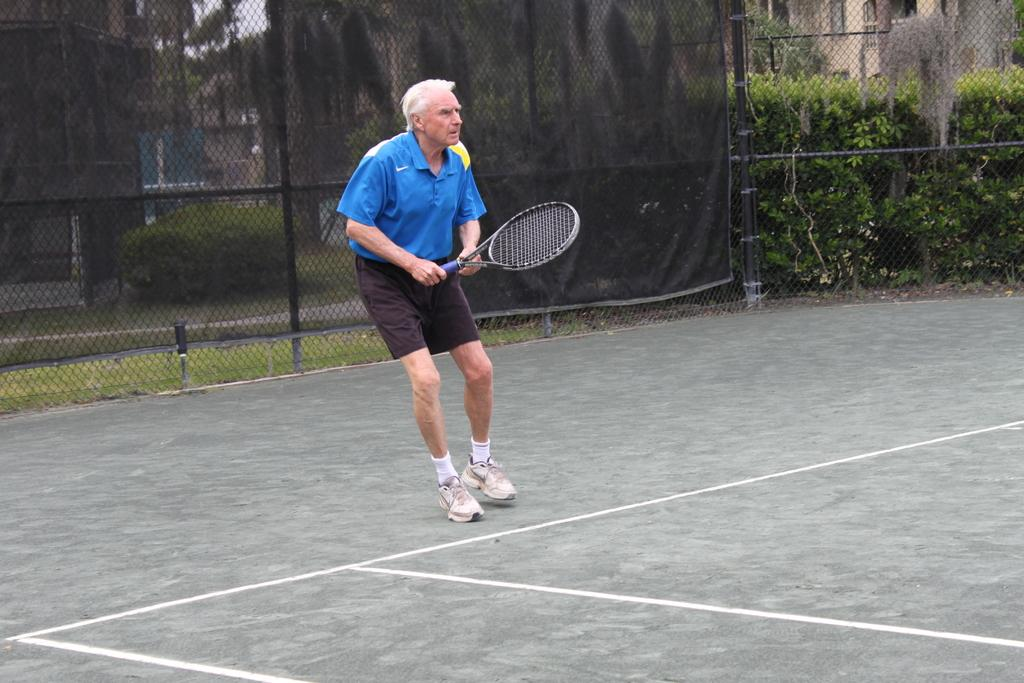What is the man in the image doing? The man is playing with a bat in the image. What can be seen in the background of the image? There is a railing, a tree, and a building in the background of the image. What might the man be playing with the bat? The man might be playing a sport, such as baseball or cricket, with the bat. What type of dog is sitting next to the man in the image? There is no dog present in the image; only the man, the bat, and the background elements are visible. 